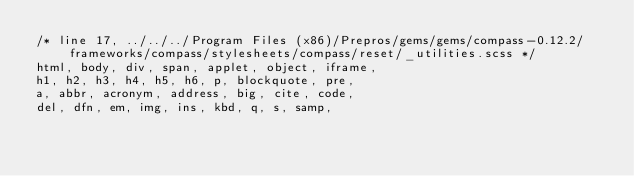<code> <loc_0><loc_0><loc_500><loc_500><_CSS_>/* line 17, ../../../Program Files (x86)/Prepros/gems/gems/compass-0.12.2/frameworks/compass/stylesheets/compass/reset/_utilities.scss */
html, body, div, span, applet, object, iframe,
h1, h2, h3, h4, h5, h6, p, blockquote, pre,
a, abbr, acronym, address, big, cite, code,
del, dfn, em, img, ins, kbd, q, s, samp,</code> 